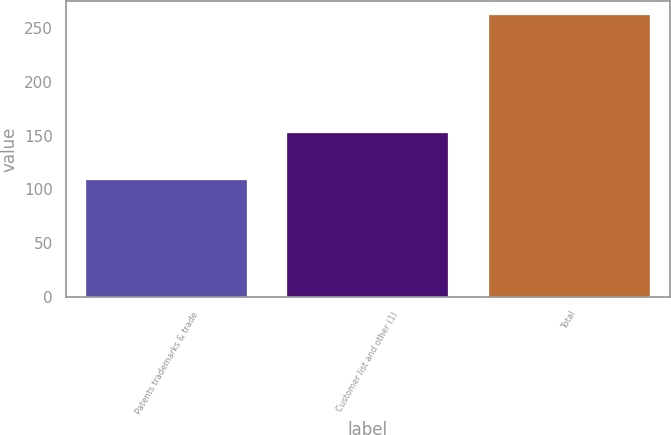<chart> <loc_0><loc_0><loc_500><loc_500><bar_chart><fcel>Patents trademarks & trade<fcel>Customer list and other (1)<fcel>Total<nl><fcel>109<fcel>153<fcel>262<nl></chart> 